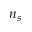Convert formula to latex. <formula><loc_0><loc_0><loc_500><loc_500>n _ { s }</formula> 